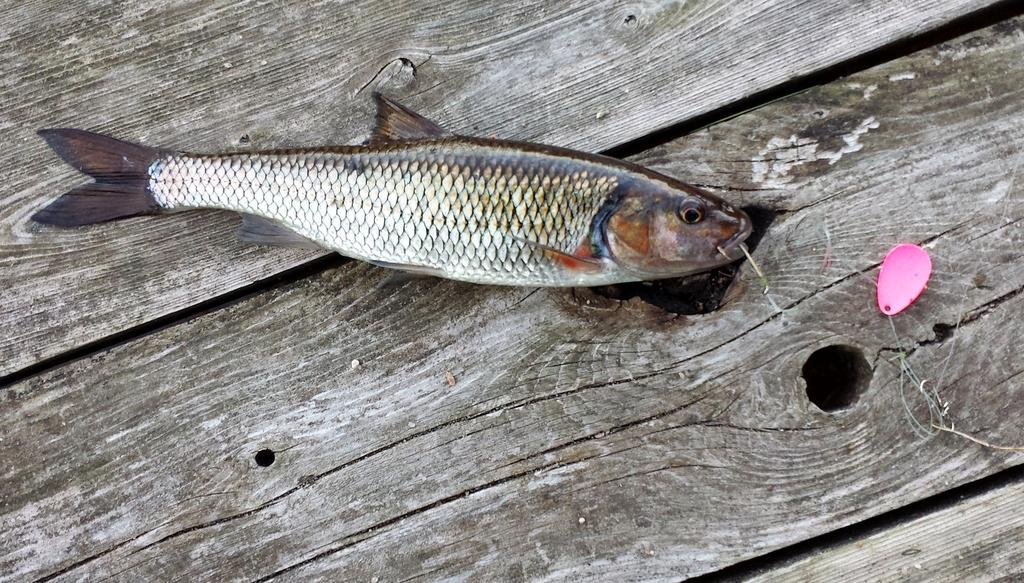What is on the surface in the image? There is a fish on the surface in the image. What does the surface resemble? The surface resembles a table. Can you describe the object in the image? Unfortunately, the facts provided do not give enough information to describe the object in the image. What color is the wound on the fish in the image? There is no wound present on the fish in the image, as it is simply a fish on a surface. 